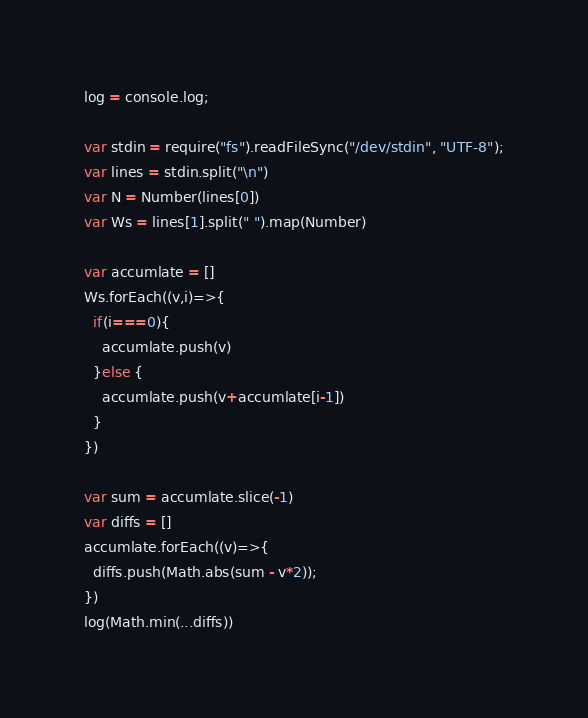<code> <loc_0><loc_0><loc_500><loc_500><_JavaScript_>log = console.log;

var stdin = require("fs").readFileSync("/dev/stdin", "UTF-8");
var lines = stdin.split("\n")
var N = Number(lines[0])
var Ws = lines[1].split(" ").map(Number)

var accumlate = []
Ws.forEach((v,i)=>{
  if(i===0){
    accumlate.push(v)
  }else {
    accumlate.push(v+accumlate[i-1])
  }
})

var sum = accumlate.slice(-1)
var diffs = []
accumlate.forEach((v)=>{
  diffs.push(Math.abs(sum - v*2));
})
log(Math.min(...diffs))</code> 